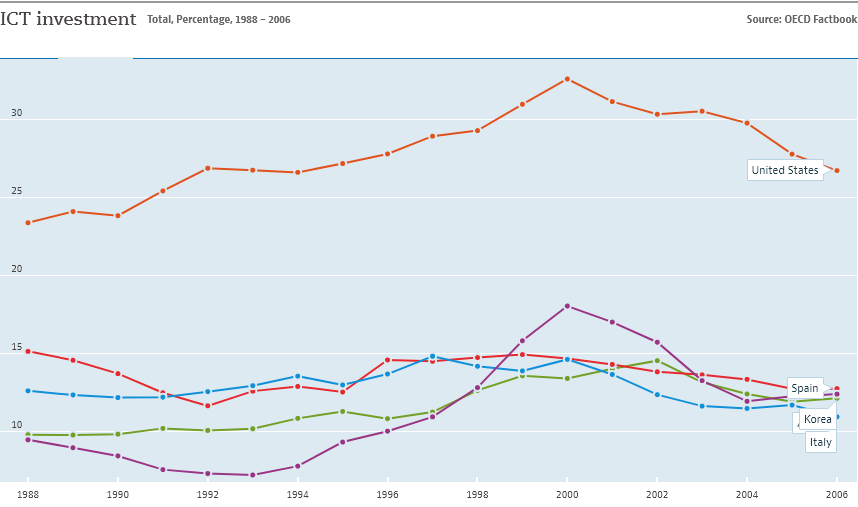Mention a couple of crucial points in this snapshot. In 1993, the violet color line experienced its lowest dip. The color orange represents the United States of America. 